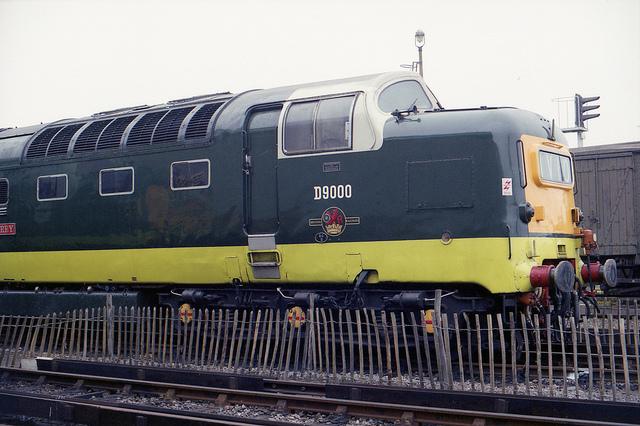What numbers are on the train?
Give a very brief answer. 9000. Is the front of the train?
Short answer required. Yes. Is this a new train?
Be succinct. Yes. 